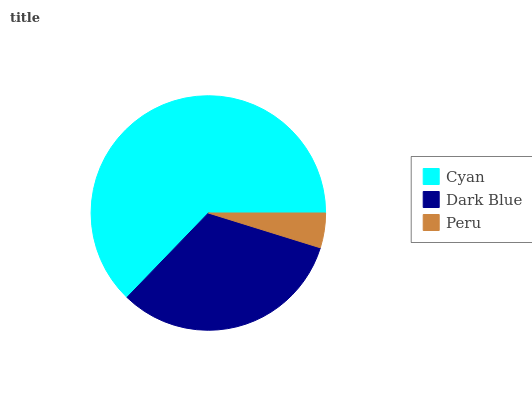Is Peru the minimum?
Answer yes or no. Yes. Is Cyan the maximum?
Answer yes or no. Yes. Is Dark Blue the minimum?
Answer yes or no. No. Is Dark Blue the maximum?
Answer yes or no. No. Is Cyan greater than Dark Blue?
Answer yes or no. Yes. Is Dark Blue less than Cyan?
Answer yes or no. Yes. Is Dark Blue greater than Cyan?
Answer yes or no. No. Is Cyan less than Dark Blue?
Answer yes or no. No. Is Dark Blue the high median?
Answer yes or no. Yes. Is Dark Blue the low median?
Answer yes or no. Yes. Is Peru the high median?
Answer yes or no. No. Is Peru the low median?
Answer yes or no. No. 